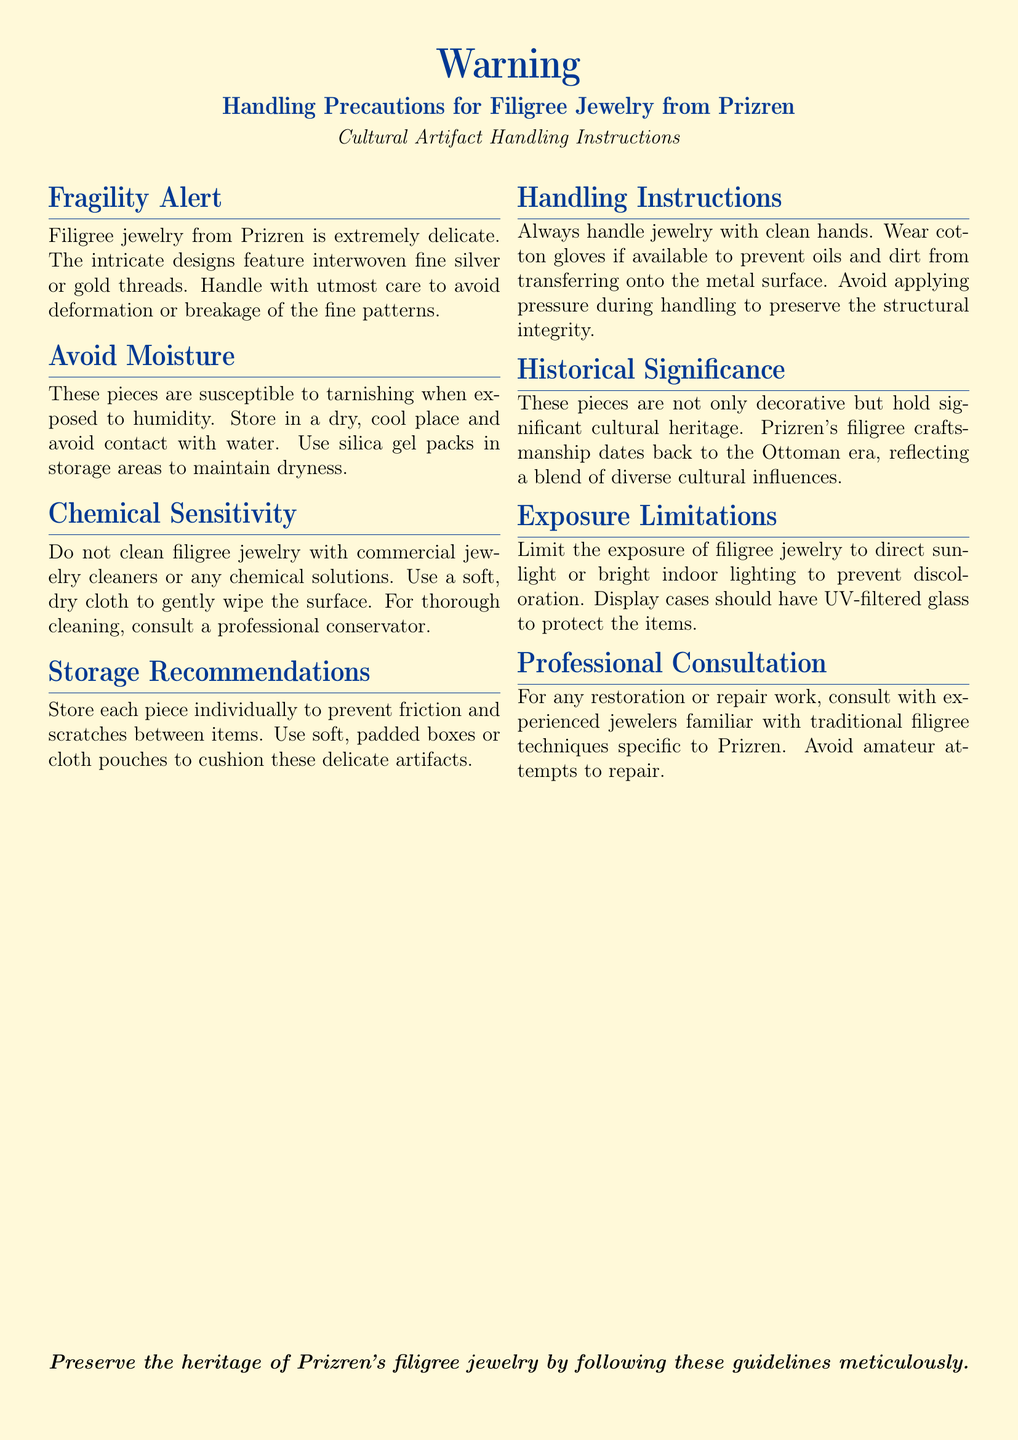What is the primary material used in filigree jewelry? The document states that the intricate designs feature interwoven fine silver or gold threads.
Answer: Silver or gold What is advised to use in storage areas? The document recommends using silica gel packs to maintain dryness in storage areas.
Answer: Silica gel packs Why should filigree jewelry be handled carefully? The document explains that filigree jewelry is extremely delicate and can be deformed or broken.
Answer: Deformation or breakage What is the recommended cleaning method for filigree jewelry? The document suggests using a soft, dry cloth to gently wipe the surface.
Answer: Soft, dry cloth What historical period does Prizren's filigree craftsmanship date back to? The document notes that it dates back to the Ottoman era.
Answer: Ottoman era What type of gloves should be worn when handling the jewelry? The document mentions wearing cotton gloves if available to prevent oils and dirt transfer.
Answer: Cotton gloves How should filigree jewelry be stored to avoid scratches? The document advises storing each piece individually in soft, padded boxes or cloth pouches.
Answer: Soft, padded boxes or cloth pouches What should be limited to prevent discoloration of the jewelry? According to the document, limit exposure to direct sunlight or bright indoor lighting.
Answer: Direct sunlight Who should be consulted for restoration work on the jewelry? The document recommends consulting experienced jewelers familiar with traditional filigree techniques.
Answer: Experienced jewelers 